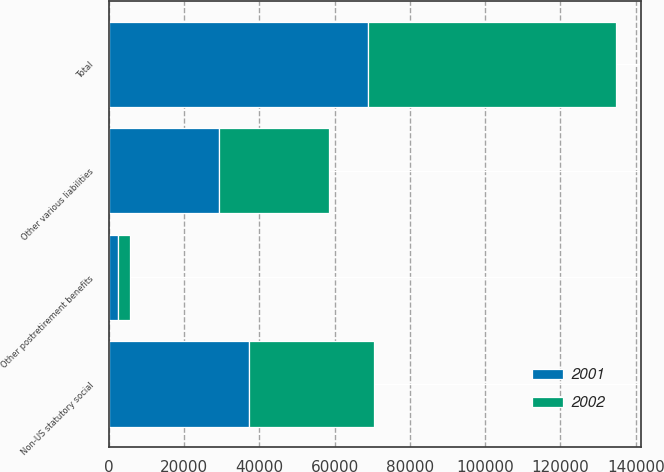Convert chart. <chart><loc_0><loc_0><loc_500><loc_500><stacked_bar_chart><ecel><fcel>Other postretirement benefits<fcel>Non-US statutory social<fcel>Other various liabilities<fcel>Total<nl><fcel>2001<fcel>2470<fcel>37128<fcel>29382<fcel>68980<nl><fcel>2002<fcel>3082<fcel>33395<fcel>29205<fcel>65682<nl></chart> 